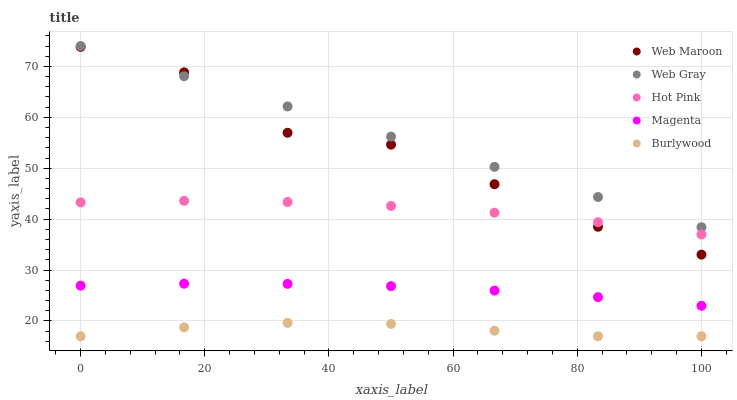Does Burlywood have the minimum area under the curve?
Answer yes or no. Yes. Does Web Gray have the maximum area under the curve?
Answer yes or no. Yes. Does Magenta have the minimum area under the curve?
Answer yes or no. No. Does Magenta have the maximum area under the curve?
Answer yes or no. No. Is Web Gray the smoothest?
Answer yes or no. Yes. Is Web Maroon the roughest?
Answer yes or no. Yes. Is Magenta the smoothest?
Answer yes or no. No. Is Magenta the roughest?
Answer yes or no. No. Does Burlywood have the lowest value?
Answer yes or no. Yes. Does Magenta have the lowest value?
Answer yes or no. No. Does Web Gray have the highest value?
Answer yes or no. Yes. Does Magenta have the highest value?
Answer yes or no. No. Is Magenta less than Hot Pink?
Answer yes or no. Yes. Is Magenta greater than Burlywood?
Answer yes or no. Yes. Does Web Maroon intersect Hot Pink?
Answer yes or no. Yes. Is Web Maroon less than Hot Pink?
Answer yes or no. No. Is Web Maroon greater than Hot Pink?
Answer yes or no. No. Does Magenta intersect Hot Pink?
Answer yes or no. No. 